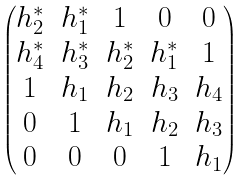<formula> <loc_0><loc_0><loc_500><loc_500>\begin{pmatrix} { h ^ { * } _ { 2 } } & h ^ { * } _ { 1 } & 1 & 0 & 0 \\ h ^ { * } _ { 4 } & { h ^ { * } _ { 3 } } & h ^ { * } _ { 2 } & h ^ { * } _ { 1 } & 1 \\ 1 & h _ { 1 } & { h _ { 2 } } & h _ { 3 } & h _ { 4 } \\ 0 & 1 & h _ { 1 } & { h _ { 2 } } & h _ { 3 } \\ 0 & 0 & 0 & 1 & { h _ { 1 } } \end{pmatrix}</formula> 